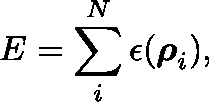<formula> <loc_0><loc_0><loc_500><loc_500>E = \sum _ { i } ^ { N } \epsilon ( \rho _ { i } ) ,</formula> 